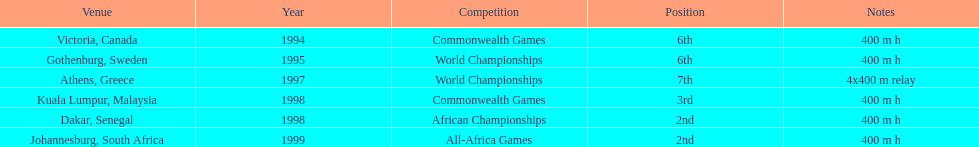What is the total number of competitions on this chart? 6. 